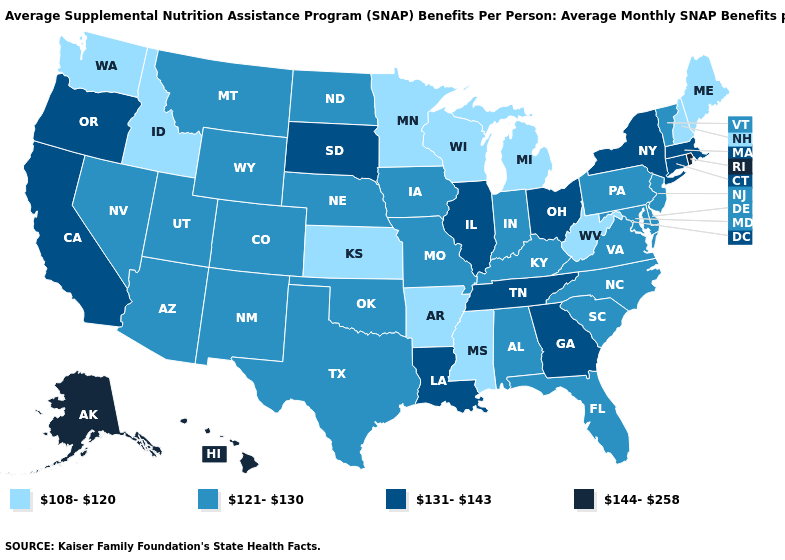What is the value of Virginia?
Answer briefly. 121-130. Among the states that border Illinois , does Indiana have the lowest value?
Quick response, please. No. Does Alabama have the lowest value in the USA?
Keep it brief. No. Which states have the lowest value in the USA?
Keep it brief. Arkansas, Idaho, Kansas, Maine, Michigan, Minnesota, Mississippi, New Hampshire, Washington, West Virginia, Wisconsin. What is the value of Florida?
Give a very brief answer. 121-130. What is the value of Tennessee?
Write a very short answer. 131-143. What is the value of South Dakota?
Write a very short answer. 131-143. Does the map have missing data?
Answer briefly. No. Does the first symbol in the legend represent the smallest category?
Short answer required. Yes. What is the value of Florida?
Be succinct. 121-130. Which states hav the highest value in the West?
Write a very short answer. Alaska, Hawaii. Which states hav the highest value in the MidWest?
Keep it brief. Illinois, Ohio, South Dakota. What is the value of Vermont?
Be succinct. 121-130. Name the states that have a value in the range 108-120?
Concise answer only. Arkansas, Idaho, Kansas, Maine, Michigan, Minnesota, Mississippi, New Hampshire, Washington, West Virginia, Wisconsin. Which states have the lowest value in the Northeast?
Be succinct. Maine, New Hampshire. 